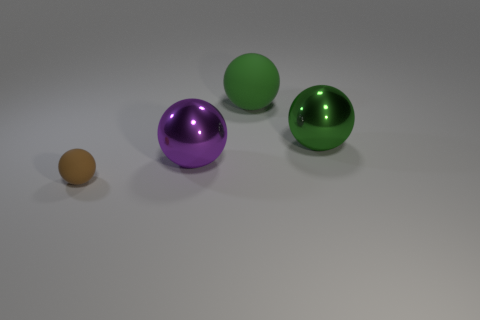Is there anything else that is the same size as the brown rubber sphere?
Offer a terse response. No. Do the brown matte object and the matte object behind the tiny sphere have the same shape?
Your response must be concise. Yes. There is a ball that is both on the right side of the brown matte ball and to the left of the green matte thing; what color is it?
Give a very brief answer. Purple. Are there any big gray cubes?
Your answer should be very brief. No. Are there the same number of large green metal things that are on the left side of the small matte object and small blue shiny cylinders?
Offer a very short reply. Yes. How many other things are the same shape as the tiny brown object?
Your response must be concise. 3. What is the shape of the large purple object?
Ensure brevity in your answer.  Sphere. Is the purple sphere made of the same material as the brown object?
Offer a terse response. No. Are there the same number of brown matte spheres on the left side of the green matte thing and green things that are to the left of the brown rubber sphere?
Provide a succinct answer. No. There is a rubber sphere behind the sphere in front of the purple thing; are there any matte things right of it?
Give a very brief answer. No. 